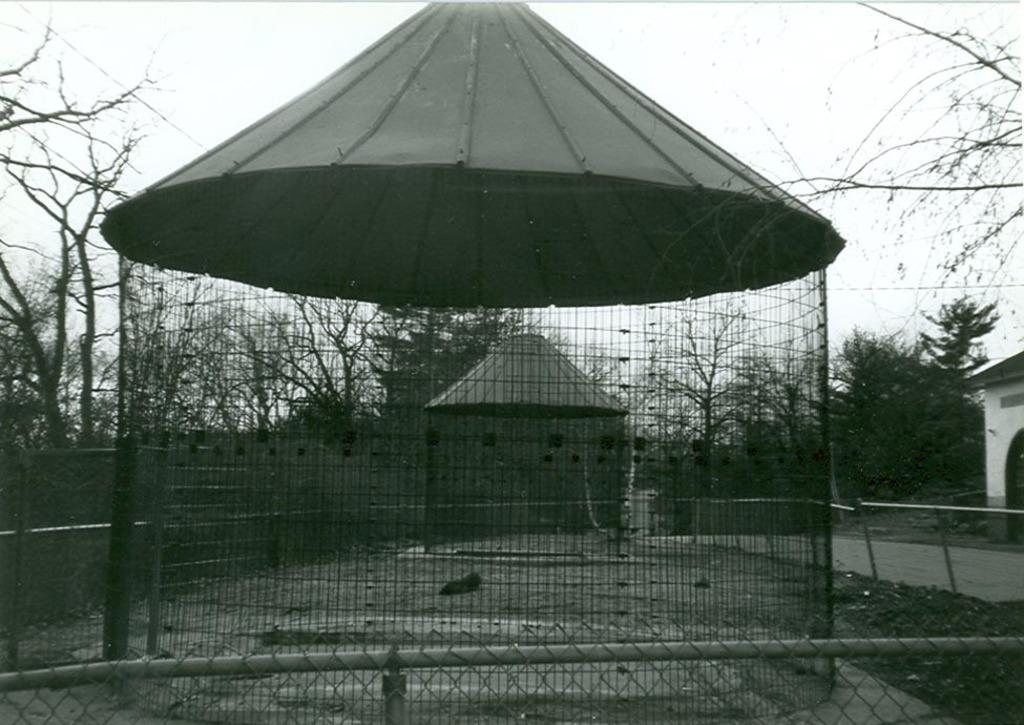What is the main object in the middle of the image? There is a big cage in the middle of the image. What can be seen in the background of the image? There is a hut and trees. What is visible above the cage and hut in the image? The sky is visible in the image. What is the color scheme of the image? The image is black and white. How many lamps are hanging from the top of the cage in the image? There are no lamps present in the image; it is a black and white image with a big cage, a hut, trees, and the sky visible. 